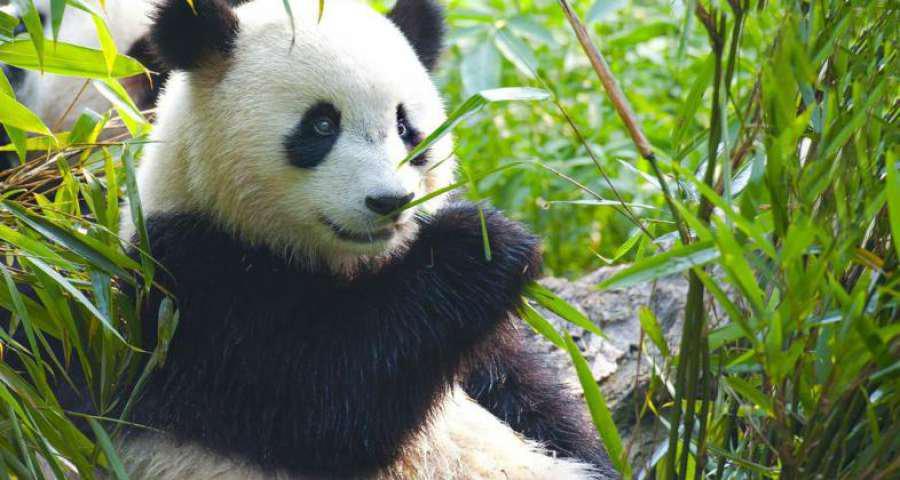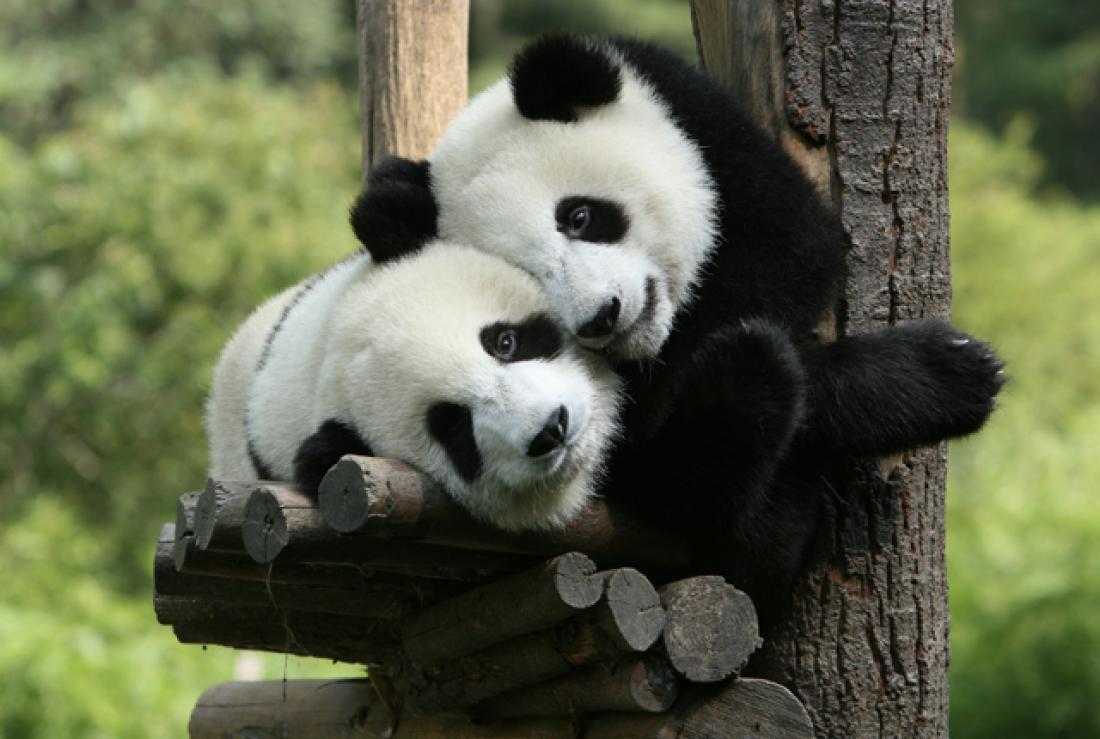The first image is the image on the left, the second image is the image on the right. For the images displayed, is the sentence "Each image shows a trio of pandas grouped closed together, and the right image shows pandas forming a pyramid shape on a ground of greenery." factually correct? Answer yes or no. No. 